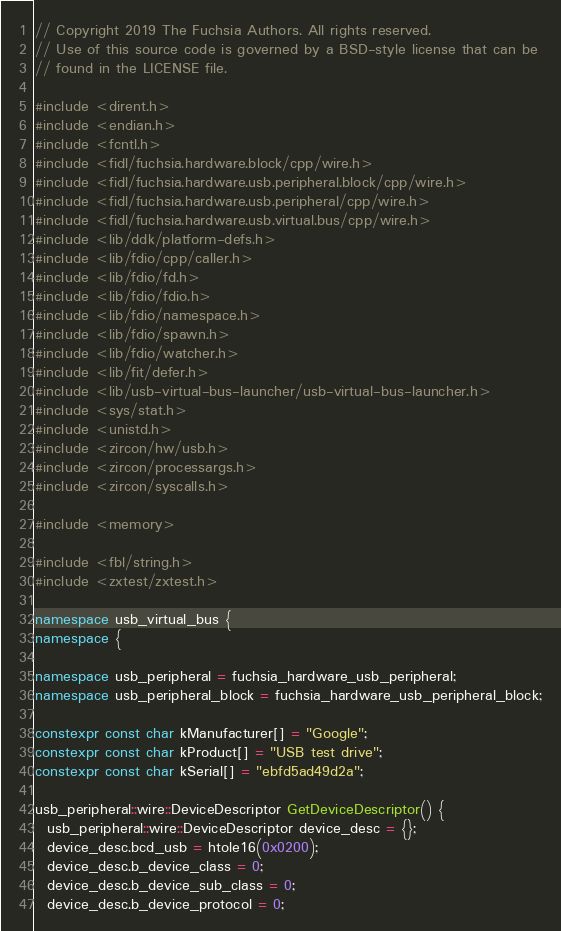Convert code to text. <code><loc_0><loc_0><loc_500><loc_500><_C++_>// Copyright 2019 The Fuchsia Authors. All rights reserved.
// Use of this source code is governed by a BSD-style license that can be
// found in the LICENSE file.

#include <dirent.h>
#include <endian.h>
#include <fcntl.h>
#include <fidl/fuchsia.hardware.block/cpp/wire.h>
#include <fidl/fuchsia.hardware.usb.peripheral.block/cpp/wire.h>
#include <fidl/fuchsia.hardware.usb.peripheral/cpp/wire.h>
#include <fidl/fuchsia.hardware.usb.virtual.bus/cpp/wire.h>
#include <lib/ddk/platform-defs.h>
#include <lib/fdio/cpp/caller.h>
#include <lib/fdio/fd.h>
#include <lib/fdio/fdio.h>
#include <lib/fdio/namespace.h>
#include <lib/fdio/spawn.h>
#include <lib/fdio/watcher.h>
#include <lib/fit/defer.h>
#include <lib/usb-virtual-bus-launcher/usb-virtual-bus-launcher.h>
#include <sys/stat.h>
#include <unistd.h>
#include <zircon/hw/usb.h>
#include <zircon/processargs.h>
#include <zircon/syscalls.h>

#include <memory>

#include <fbl/string.h>
#include <zxtest/zxtest.h>

namespace usb_virtual_bus {
namespace {

namespace usb_peripheral = fuchsia_hardware_usb_peripheral;
namespace usb_peripheral_block = fuchsia_hardware_usb_peripheral_block;

constexpr const char kManufacturer[] = "Google";
constexpr const char kProduct[] = "USB test drive";
constexpr const char kSerial[] = "ebfd5ad49d2a";

usb_peripheral::wire::DeviceDescriptor GetDeviceDescriptor() {
  usb_peripheral::wire::DeviceDescriptor device_desc = {};
  device_desc.bcd_usb = htole16(0x0200);
  device_desc.b_device_class = 0;
  device_desc.b_device_sub_class = 0;
  device_desc.b_device_protocol = 0;</code> 